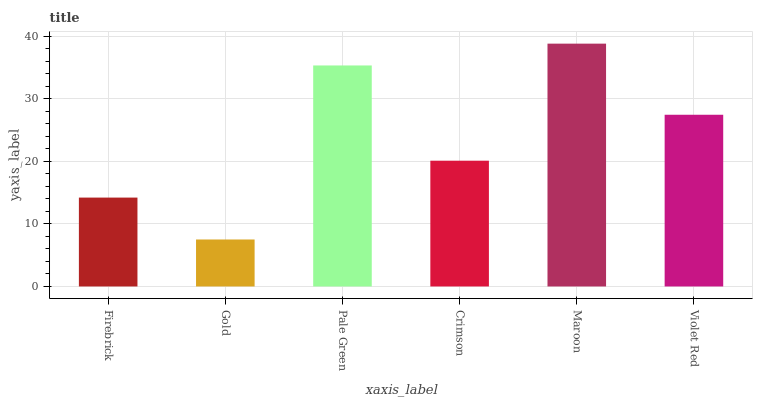Is Pale Green the minimum?
Answer yes or no. No. Is Pale Green the maximum?
Answer yes or no. No. Is Pale Green greater than Gold?
Answer yes or no. Yes. Is Gold less than Pale Green?
Answer yes or no. Yes. Is Gold greater than Pale Green?
Answer yes or no. No. Is Pale Green less than Gold?
Answer yes or no. No. Is Violet Red the high median?
Answer yes or no. Yes. Is Crimson the low median?
Answer yes or no. Yes. Is Pale Green the high median?
Answer yes or no. No. Is Violet Red the low median?
Answer yes or no. No. 